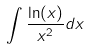Convert formula to latex. <formula><loc_0><loc_0><loc_500><loc_500>\int \frac { \ln ( x ) } { x ^ { 2 } } d x</formula> 